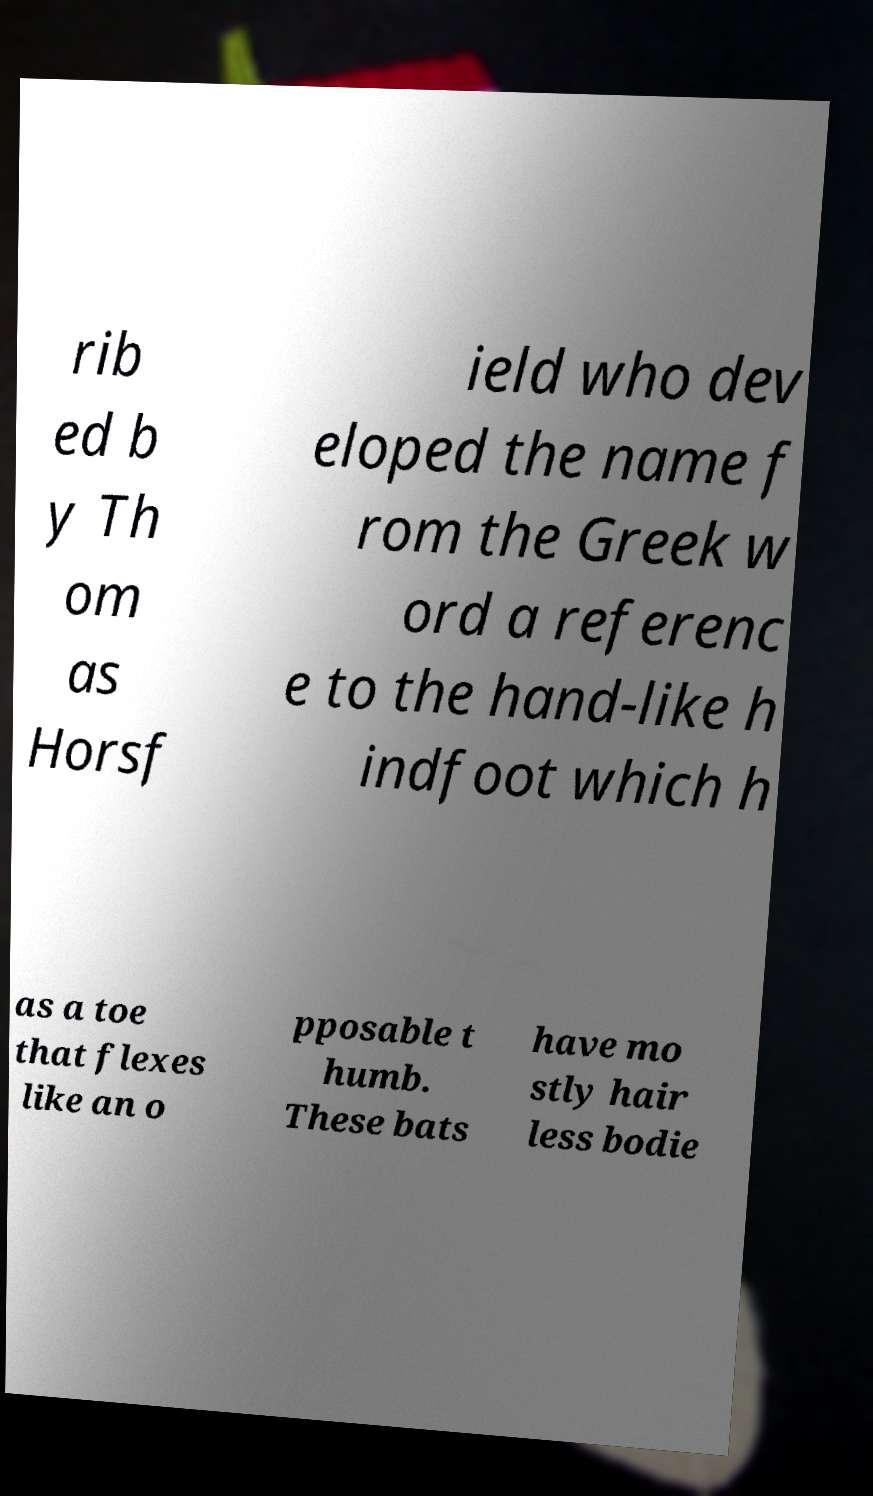For documentation purposes, I need the text within this image transcribed. Could you provide that? rib ed b y Th om as Horsf ield who dev eloped the name f rom the Greek w ord a referenc e to the hand-like h indfoot which h as a toe that flexes like an o pposable t humb. These bats have mo stly hair less bodie 